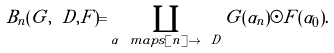<formula> <loc_0><loc_0><loc_500><loc_500>B _ { n } ( G , \ D , F ) = \coprod _ { \alpha \ m a p s [ n ] \to \ D } G ( \alpha _ { n } ) \odot F ( \alpha _ { 0 } ) .</formula> 